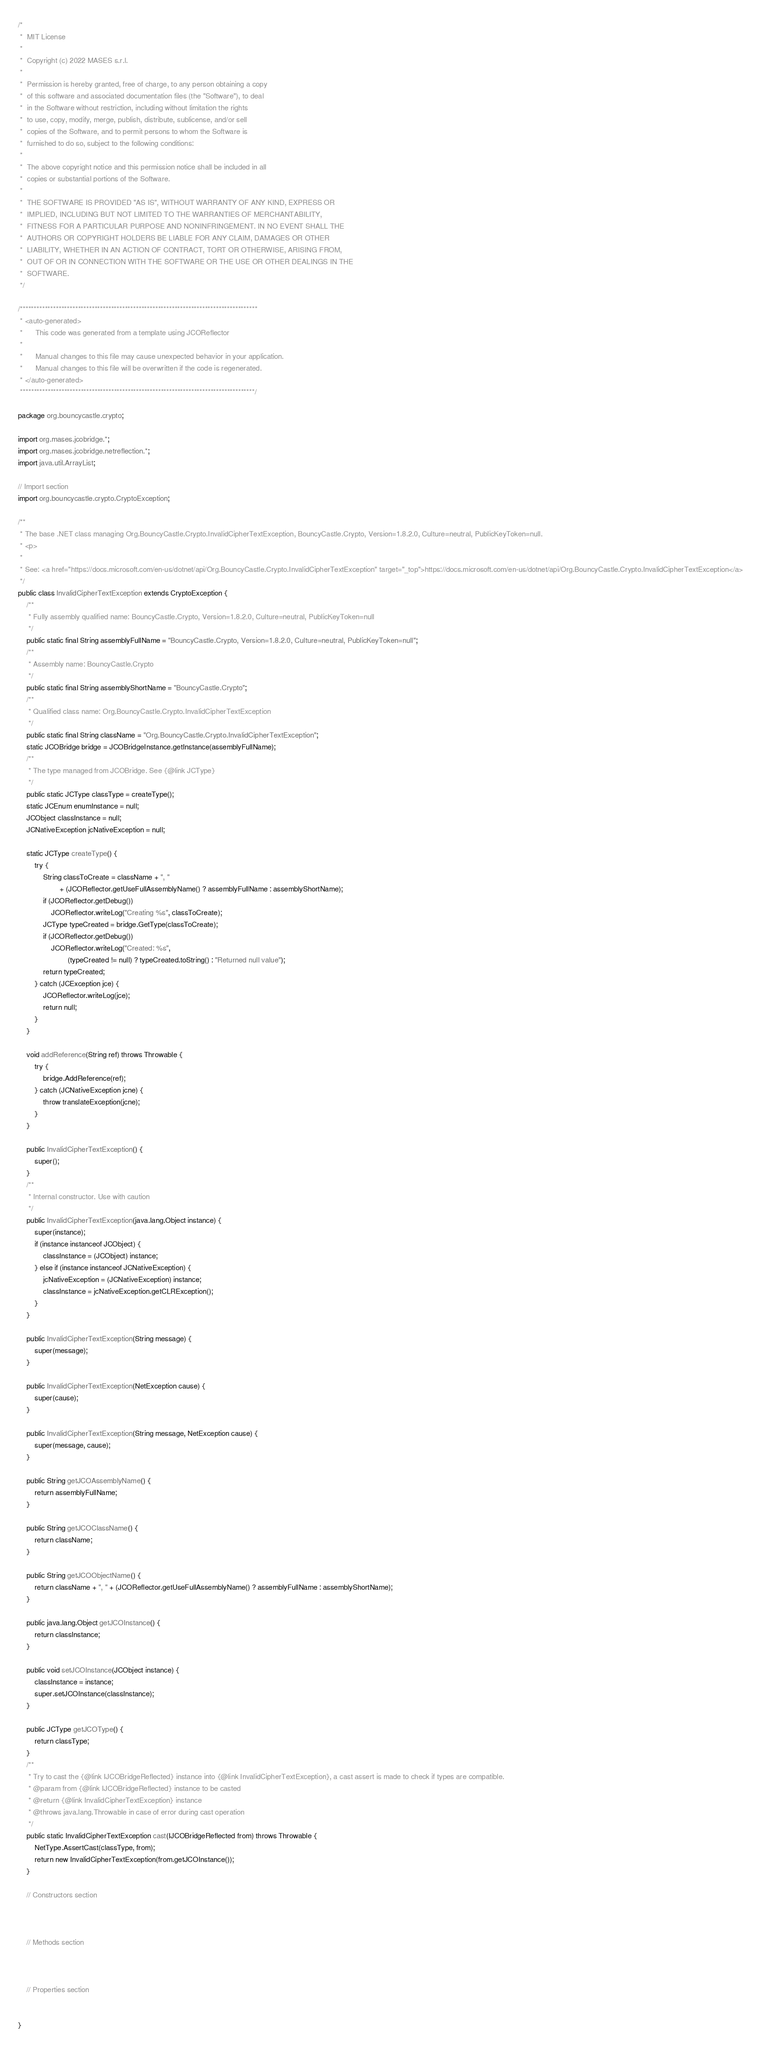<code> <loc_0><loc_0><loc_500><loc_500><_Java_>/*
 *  MIT License
 *
 *  Copyright (c) 2022 MASES s.r.l.
 *
 *  Permission is hereby granted, free of charge, to any person obtaining a copy
 *  of this software and associated documentation files (the "Software"), to deal
 *  in the Software without restriction, including without limitation the rights
 *  to use, copy, modify, merge, publish, distribute, sublicense, and/or sell
 *  copies of the Software, and to permit persons to whom the Software is
 *  furnished to do so, subject to the following conditions:
 *
 *  The above copyright notice and this permission notice shall be included in all
 *  copies or substantial portions of the Software.
 *
 *  THE SOFTWARE IS PROVIDED "AS IS", WITHOUT WARRANTY OF ANY KIND, EXPRESS OR
 *  IMPLIED, INCLUDING BUT NOT LIMITED TO THE WARRANTIES OF MERCHANTABILITY,
 *  FITNESS FOR A PARTICULAR PURPOSE AND NONINFRINGEMENT. IN NO EVENT SHALL THE
 *  AUTHORS OR COPYRIGHT HOLDERS BE LIABLE FOR ANY CLAIM, DAMAGES OR OTHER
 *  LIABILITY, WHETHER IN AN ACTION OF CONTRACT, TORT OR OTHERWISE, ARISING FROM,
 *  OUT OF OR IN CONNECTION WITH THE SOFTWARE OR THE USE OR OTHER DEALINGS IN THE
 *  SOFTWARE.
 */

/**************************************************************************************
 * <auto-generated>
 *      This code was generated from a template using JCOReflector
 * 
 *      Manual changes to this file may cause unexpected behavior in your application.
 *      Manual changes to this file will be overwritten if the code is regenerated.
 * </auto-generated>
 *************************************************************************************/

package org.bouncycastle.crypto;

import org.mases.jcobridge.*;
import org.mases.jcobridge.netreflection.*;
import java.util.ArrayList;

// Import section
import org.bouncycastle.crypto.CryptoException;

/**
 * The base .NET class managing Org.BouncyCastle.Crypto.InvalidCipherTextException, BouncyCastle.Crypto, Version=1.8.2.0, Culture=neutral, PublicKeyToken=null.
 * <p>
 * 
 * See: <a href="https://docs.microsoft.com/en-us/dotnet/api/Org.BouncyCastle.Crypto.InvalidCipherTextException" target="_top">https://docs.microsoft.com/en-us/dotnet/api/Org.BouncyCastle.Crypto.InvalidCipherTextException</a>
 */
public class InvalidCipherTextException extends CryptoException {
    /**
     * Fully assembly qualified name: BouncyCastle.Crypto, Version=1.8.2.0, Culture=neutral, PublicKeyToken=null
     */
    public static final String assemblyFullName = "BouncyCastle.Crypto, Version=1.8.2.0, Culture=neutral, PublicKeyToken=null";
    /**
     * Assembly name: BouncyCastle.Crypto
     */
    public static final String assemblyShortName = "BouncyCastle.Crypto";
    /**
     * Qualified class name: Org.BouncyCastle.Crypto.InvalidCipherTextException
     */
    public static final String className = "Org.BouncyCastle.Crypto.InvalidCipherTextException";
    static JCOBridge bridge = JCOBridgeInstance.getInstance(assemblyFullName);
    /**
     * The type managed from JCOBridge. See {@link JCType}
     */
    public static JCType classType = createType();
    static JCEnum enumInstance = null;
    JCObject classInstance = null;
    JCNativeException jcNativeException = null;

    static JCType createType() {
        try {
            String classToCreate = className + ", "
                    + (JCOReflector.getUseFullAssemblyName() ? assemblyFullName : assemblyShortName);
            if (JCOReflector.getDebug())
                JCOReflector.writeLog("Creating %s", classToCreate);
            JCType typeCreated = bridge.GetType(classToCreate);
            if (JCOReflector.getDebug())
                JCOReflector.writeLog("Created: %s",
                        (typeCreated != null) ? typeCreated.toString() : "Returned null value");
            return typeCreated;
        } catch (JCException jce) {
            JCOReflector.writeLog(jce);
            return null;
        }
    }

    void addReference(String ref) throws Throwable {
        try {
            bridge.AddReference(ref);
        } catch (JCNativeException jcne) {
            throw translateException(jcne);
        }
    }

    public InvalidCipherTextException() {
        super();
    }
    /**
     * Internal constructor. Use with caution 
     */
    public InvalidCipherTextException(java.lang.Object instance) {
        super(instance);
        if (instance instanceof JCObject) {
            classInstance = (JCObject) instance;
        } else if (instance instanceof JCNativeException) {
            jcNativeException = (JCNativeException) instance;
            classInstance = jcNativeException.getCLRException();
        }
    }

    public InvalidCipherTextException(String message) {
        super(message);
    }

    public InvalidCipherTextException(NetException cause) {
        super(cause);
    }

    public InvalidCipherTextException(String message, NetException cause) {
        super(message, cause);
    }

    public String getJCOAssemblyName() {
        return assemblyFullName;
    }

    public String getJCOClassName() {
        return className;
    }

    public String getJCOObjectName() {
        return className + ", " + (JCOReflector.getUseFullAssemblyName() ? assemblyFullName : assemblyShortName);
    }

    public java.lang.Object getJCOInstance() {
        return classInstance;
    }

    public void setJCOInstance(JCObject instance) {
        classInstance = instance;
        super.setJCOInstance(classInstance);
    }

    public JCType getJCOType() {
        return classType;
    }
    /**
     * Try to cast the {@link IJCOBridgeReflected} instance into {@link InvalidCipherTextException}, a cast assert is made to check if types are compatible.
     * @param from {@link IJCOBridgeReflected} instance to be casted
     * @return {@link InvalidCipherTextException} instance
     * @throws java.lang.Throwable in case of error during cast operation
     */
    public static InvalidCipherTextException cast(IJCOBridgeReflected from) throws Throwable {
        NetType.AssertCast(classType, from);
        return new InvalidCipherTextException(from.getJCOInstance());
    }

    // Constructors section
    

    
    // Methods section
    

    
    // Properties section
    

}</code> 